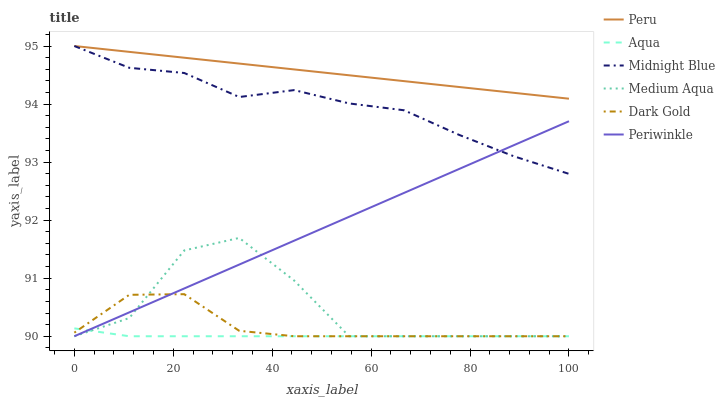Does Dark Gold have the minimum area under the curve?
Answer yes or no. No. Does Dark Gold have the maximum area under the curve?
Answer yes or no. No. Is Dark Gold the smoothest?
Answer yes or no. No. Is Dark Gold the roughest?
Answer yes or no. No. Does Peru have the lowest value?
Answer yes or no. No. Does Dark Gold have the highest value?
Answer yes or no. No. Is Medium Aqua less than Peru?
Answer yes or no. Yes. Is Peru greater than Periwinkle?
Answer yes or no. Yes. Does Medium Aqua intersect Peru?
Answer yes or no. No. 